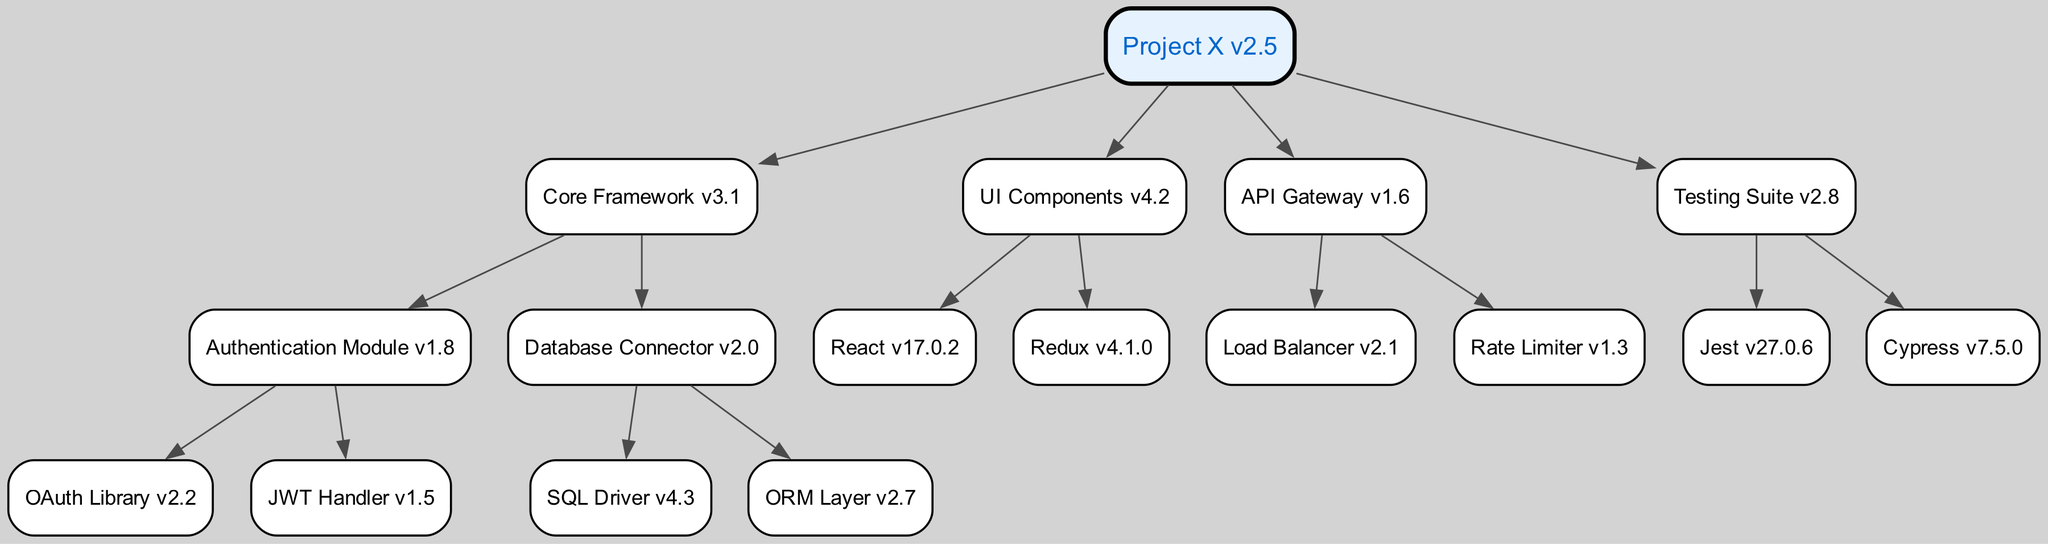What is the version of the API Gateway? The diagram shows the API Gateway module, which is labeled with the version "1.6".
Answer: 1.6 How many child modules does the Core Framework have? In the diagram, the Core Framework is connected to two modules: Authentication Module and Database Connector, which counts as two child nodes.
Answer: 2 Which module is directly below the UI Components? The diagram indicates that the UI Components has two children, React and Redux. Since the question asks for the direct child, I can refer to either; React is the first in the list.
Answer: React What is the relationship between the Testing Suite and its child modules? The Testing Suite directly connects to its two children, Jest and Cypress, indicating that both are dependencies of the Testing Suite.
Answer: Jest and Cypress How many total modules are there in the project? Starting from the root and counting all child modules down the hierarchy, I find the following: Project X (1), Core Framework (1), Authentication Module (1), OAuth Library (1), JWT Handler (1), Database Connector (1), SQL Driver (1), ORM Layer (1), UI Components (1), React (1), Redux (1), API Gateway (1), Load Balancer (1), Rate Limiter (1), Testing Suite (1), Jest (1), and Cypress (1) – totaling 16 modules.
Answer: 16 Which module serves as the parent to the OAuth Library? The diagram indicates that the OAuth Library is a child of the Authentication Module, making the Authentication Module its parent.
Answer: Authentication Module What is the version of the Database Connector? The Database Connector is specifically labeled with the version number "2.0" in the diagram.
Answer: 2.0 Which module under the API Gateway has the lowest version number? By examining the versions of the child modules of API Gateway, Load Balancer has version "2.1" and Rate Limiter has version "1.3", meaning Rate Limiter has the lowest version number.
Answer: Rate Limiter What type of modules are represented under UI Components? The child modules of UI Components, which are React and Redux, are both front-end libraries, indicating that this module consists solely of front-end technologies.
Answer: Front-end libraries 